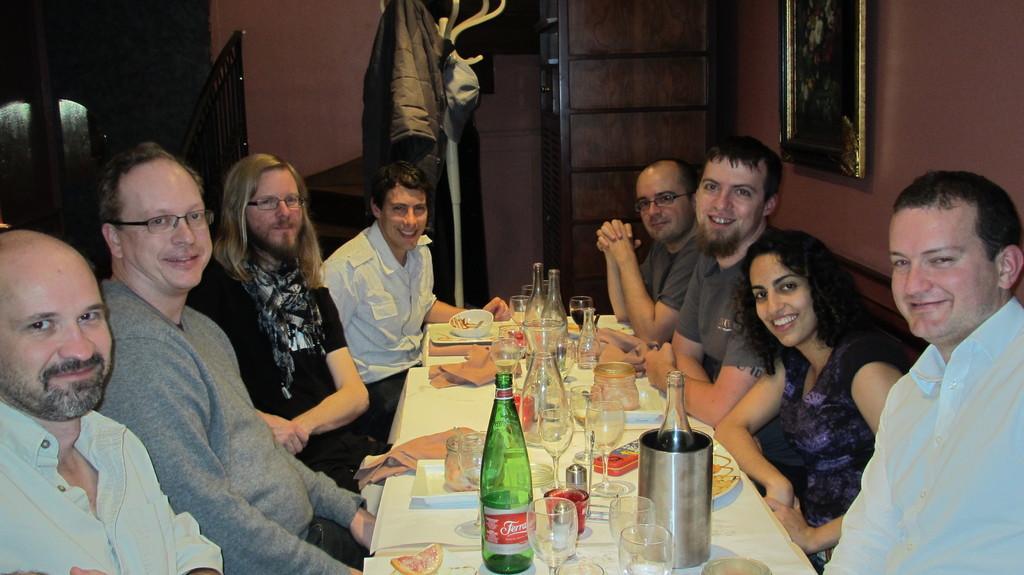In one or two sentences, can you explain what this image depicts? In the image it looks like there is a party going on between the people who are sitting near the table. On the there are wine bottles,glasses,trays,plates,bowls,drinks. At the background there is wall and clothes which are hanged to a stick. To the right corner there is a photo frame which is attached to the wall. 